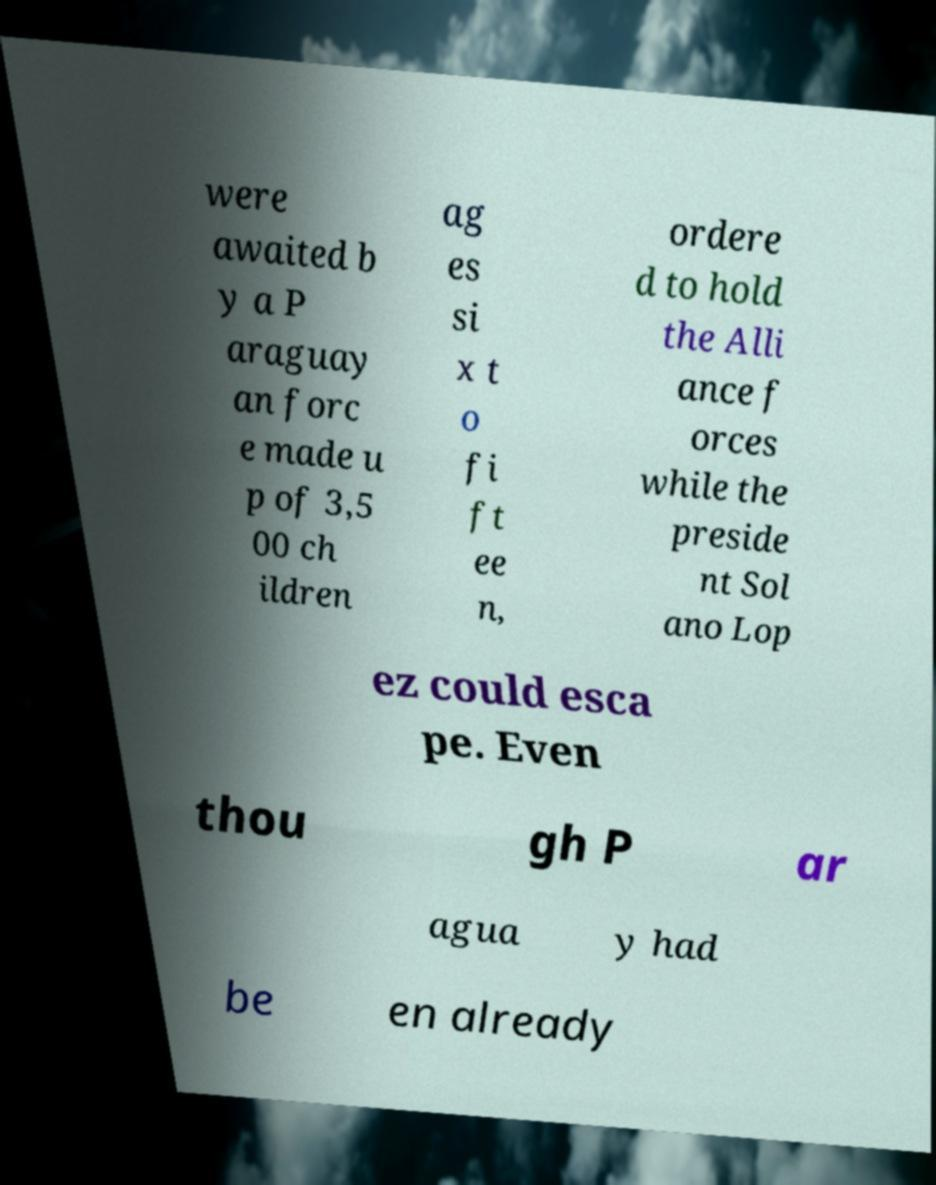What messages or text are displayed in this image? I need them in a readable, typed format. were awaited b y a P araguay an forc e made u p of 3,5 00 ch ildren ag es si x t o fi ft ee n, ordere d to hold the Alli ance f orces while the preside nt Sol ano Lop ez could esca pe. Even thou gh P ar agua y had be en already 